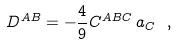<formula> <loc_0><loc_0><loc_500><loc_500>D ^ { A B } = - \frac { 4 } { 9 } C ^ { A B C } \, a _ { C } \ ,</formula> 